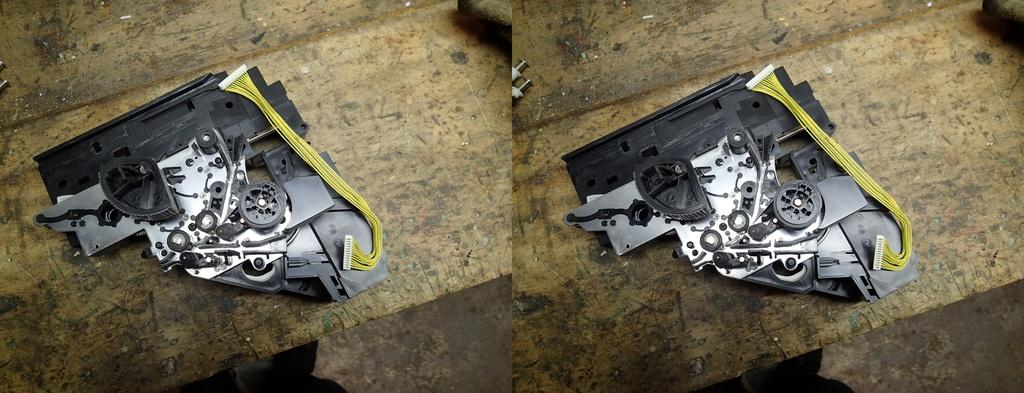What is the composition of the image? The image is a collage of two images. What can be seen in each of the images? There is an electronic device in each of the images. Where are the electronic devices located in the images? The electronic devices are on the floor in the images. What type of trees can be seen in the image? There are no trees present in the image; it is a collage of two images, each featuring an electronic device on the floor. 